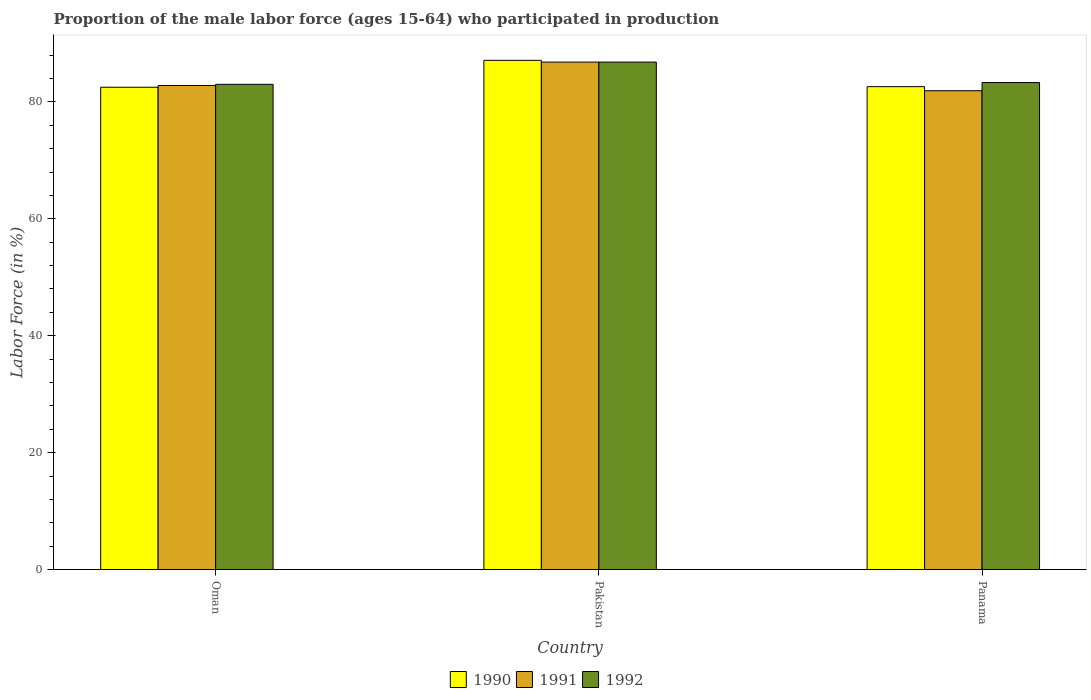How many groups of bars are there?
Offer a terse response. 3. Are the number of bars per tick equal to the number of legend labels?
Keep it short and to the point. Yes. Are the number of bars on each tick of the X-axis equal?
Offer a very short reply. Yes. How many bars are there on the 3rd tick from the right?
Make the answer very short. 3. What is the label of the 3rd group of bars from the left?
Offer a terse response. Panama. In how many cases, is the number of bars for a given country not equal to the number of legend labels?
Ensure brevity in your answer.  0. What is the proportion of the male labor force who participated in production in 1990 in Pakistan?
Give a very brief answer. 87.1. Across all countries, what is the maximum proportion of the male labor force who participated in production in 1990?
Give a very brief answer. 87.1. Across all countries, what is the minimum proportion of the male labor force who participated in production in 1992?
Provide a short and direct response. 83. In which country was the proportion of the male labor force who participated in production in 1991 minimum?
Provide a short and direct response. Panama. What is the total proportion of the male labor force who participated in production in 1992 in the graph?
Your answer should be compact. 253.1. What is the difference between the proportion of the male labor force who participated in production in 1990 in Pakistan and that in Panama?
Your response must be concise. 4.5. What is the difference between the proportion of the male labor force who participated in production in 1991 in Oman and the proportion of the male labor force who participated in production in 1992 in Pakistan?
Provide a short and direct response. -4. What is the average proportion of the male labor force who participated in production in 1990 per country?
Make the answer very short. 84.07. What is the difference between the proportion of the male labor force who participated in production of/in 1992 and proportion of the male labor force who participated in production of/in 1990 in Pakistan?
Keep it short and to the point. -0.3. In how many countries, is the proportion of the male labor force who participated in production in 1990 greater than 60 %?
Provide a short and direct response. 3. What is the ratio of the proportion of the male labor force who participated in production in 1990 in Oman to that in Pakistan?
Provide a succinct answer. 0.95. What is the difference between the highest and the second highest proportion of the male labor force who participated in production in 1992?
Give a very brief answer. -0.3. What is the difference between the highest and the lowest proportion of the male labor force who participated in production in 1991?
Make the answer very short. 4.9. Is the sum of the proportion of the male labor force who participated in production in 1992 in Pakistan and Panama greater than the maximum proportion of the male labor force who participated in production in 1991 across all countries?
Keep it short and to the point. Yes. What does the 1st bar from the right in Oman represents?
Provide a succinct answer. 1992. How many bars are there?
Offer a very short reply. 9. Are all the bars in the graph horizontal?
Provide a succinct answer. No. What is the difference between two consecutive major ticks on the Y-axis?
Make the answer very short. 20. Does the graph contain any zero values?
Offer a terse response. No. Where does the legend appear in the graph?
Keep it short and to the point. Bottom center. How many legend labels are there?
Provide a short and direct response. 3. What is the title of the graph?
Offer a very short reply. Proportion of the male labor force (ages 15-64) who participated in production. Does "1974" appear as one of the legend labels in the graph?
Your answer should be compact. No. What is the Labor Force (in %) in 1990 in Oman?
Offer a terse response. 82.5. What is the Labor Force (in %) of 1991 in Oman?
Make the answer very short. 82.8. What is the Labor Force (in %) in 1992 in Oman?
Give a very brief answer. 83. What is the Labor Force (in %) of 1990 in Pakistan?
Your answer should be compact. 87.1. What is the Labor Force (in %) of 1991 in Pakistan?
Make the answer very short. 86.8. What is the Labor Force (in %) in 1992 in Pakistan?
Give a very brief answer. 86.8. What is the Labor Force (in %) of 1990 in Panama?
Ensure brevity in your answer.  82.6. What is the Labor Force (in %) in 1991 in Panama?
Your answer should be compact. 81.9. What is the Labor Force (in %) of 1992 in Panama?
Provide a short and direct response. 83.3. Across all countries, what is the maximum Labor Force (in %) of 1990?
Your answer should be compact. 87.1. Across all countries, what is the maximum Labor Force (in %) of 1991?
Make the answer very short. 86.8. Across all countries, what is the maximum Labor Force (in %) in 1992?
Provide a short and direct response. 86.8. Across all countries, what is the minimum Labor Force (in %) of 1990?
Make the answer very short. 82.5. Across all countries, what is the minimum Labor Force (in %) of 1991?
Ensure brevity in your answer.  81.9. What is the total Labor Force (in %) of 1990 in the graph?
Your answer should be compact. 252.2. What is the total Labor Force (in %) of 1991 in the graph?
Your answer should be very brief. 251.5. What is the total Labor Force (in %) of 1992 in the graph?
Offer a terse response. 253.1. What is the difference between the Labor Force (in %) in 1990 in Oman and that in Pakistan?
Provide a succinct answer. -4.6. What is the difference between the Labor Force (in %) in 1991 in Oman and that in Pakistan?
Your answer should be very brief. -4. What is the difference between the Labor Force (in %) in 1991 in Oman and that in Panama?
Ensure brevity in your answer.  0.9. What is the difference between the Labor Force (in %) in 1992 in Oman and that in Panama?
Your answer should be compact. -0.3. What is the difference between the Labor Force (in %) in 1990 in Oman and the Labor Force (in %) in 1991 in Pakistan?
Provide a short and direct response. -4.3. What is the difference between the Labor Force (in %) of 1990 in Oman and the Labor Force (in %) of 1992 in Panama?
Your response must be concise. -0.8. What is the difference between the Labor Force (in %) in 1990 in Pakistan and the Labor Force (in %) in 1991 in Panama?
Provide a short and direct response. 5.2. What is the difference between the Labor Force (in %) of 1990 in Pakistan and the Labor Force (in %) of 1992 in Panama?
Ensure brevity in your answer.  3.8. What is the difference between the Labor Force (in %) in 1991 in Pakistan and the Labor Force (in %) in 1992 in Panama?
Your response must be concise. 3.5. What is the average Labor Force (in %) of 1990 per country?
Give a very brief answer. 84.07. What is the average Labor Force (in %) in 1991 per country?
Offer a terse response. 83.83. What is the average Labor Force (in %) of 1992 per country?
Your response must be concise. 84.37. What is the difference between the Labor Force (in %) of 1990 and Labor Force (in %) of 1991 in Pakistan?
Provide a succinct answer. 0.3. What is the difference between the Labor Force (in %) of 1990 and Labor Force (in %) of 1992 in Pakistan?
Provide a short and direct response. 0.3. What is the difference between the Labor Force (in %) of 1990 and Labor Force (in %) of 1992 in Panama?
Give a very brief answer. -0.7. What is the difference between the Labor Force (in %) in 1991 and Labor Force (in %) in 1992 in Panama?
Offer a very short reply. -1.4. What is the ratio of the Labor Force (in %) of 1990 in Oman to that in Pakistan?
Your answer should be very brief. 0.95. What is the ratio of the Labor Force (in %) in 1991 in Oman to that in Pakistan?
Make the answer very short. 0.95. What is the ratio of the Labor Force (in %) of 1992 in Oman to that in Pakistan?
Provide a succinct answer. 0.96. What is the ratio of the Labor Force (in %) of 1990 in Pakistan to that in Panama?
Make the answer very short. 1.05. What is the ratio of the Labor Force (in %) in 1991 in Pakistan to that in Panama?
Offer a very short reply. 1.06. What is the ratio of the Labor Force (in %) in 1992 in Pakistan to that in Panama?
Keep it short and to the point. 1.04. What is the difference between the highest and the second highest Labor Force (in %) in 1991?
Your response must be concise. 4. What is the difference between the highest and the second highest Labor Force (in %) of 1992?
Your answer should be very brief. 3.5. What is the difference between the highest and the lowest Labor Force (in %) in 1990?
Give a very brief answer. 4.6. What is the difference between the highest and the lowest Labor Force (in %) in 1992?
Your answer should be compact. 3.8. 